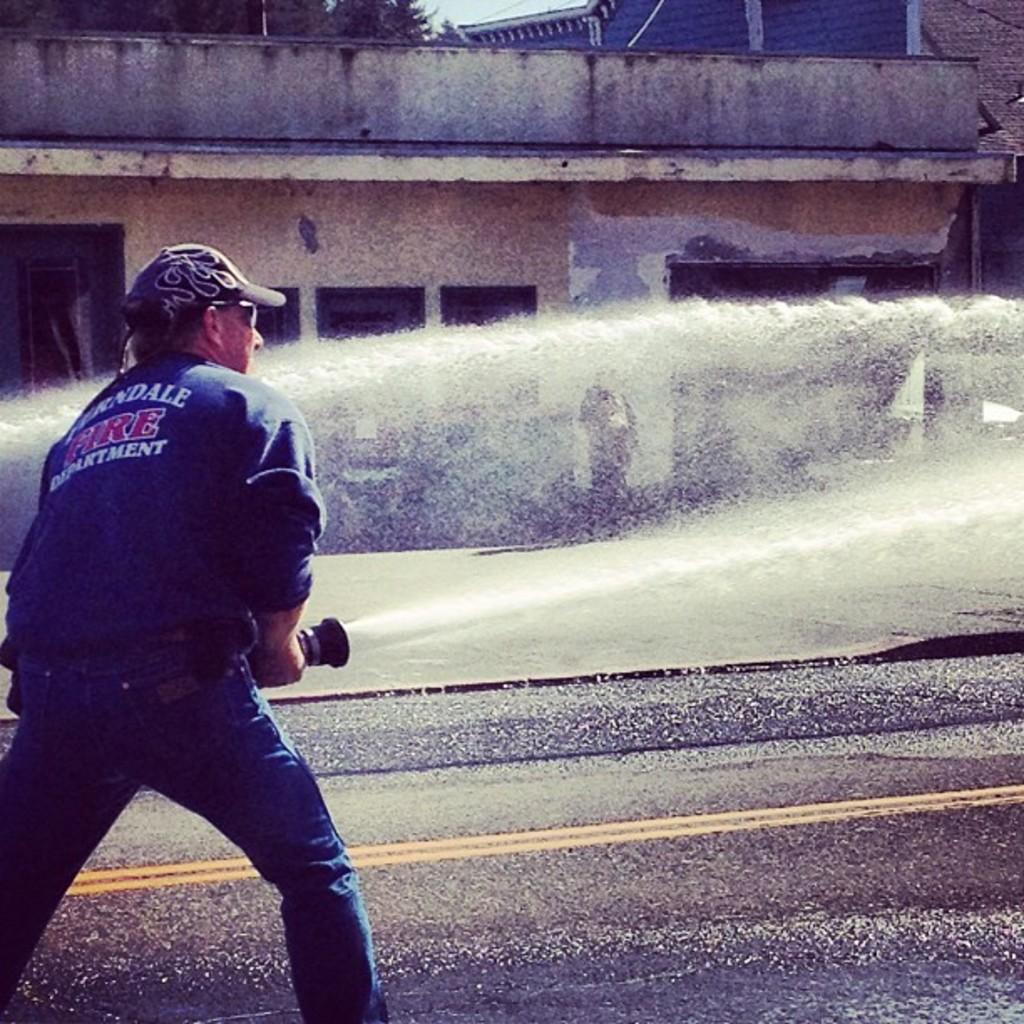What is the person in the image doing? The person is standing in the image and holding a water pipe. What is the person wearing on their head? The person is wearing a cap. What can be seen in the background of the image? There is a building, trees, and the sky visible in the background of the image. Can you describe the water in the image? Yes, there is water visible in the image. What type of apple is growing on the library in the image? There is no apple or library present in the image. 